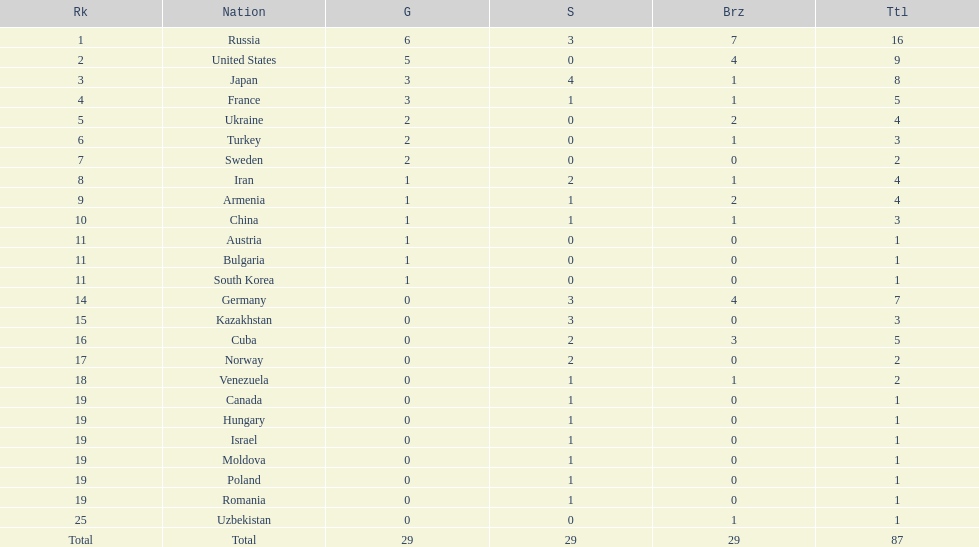Which nation obtained the greatest amount of medals? Russia. 